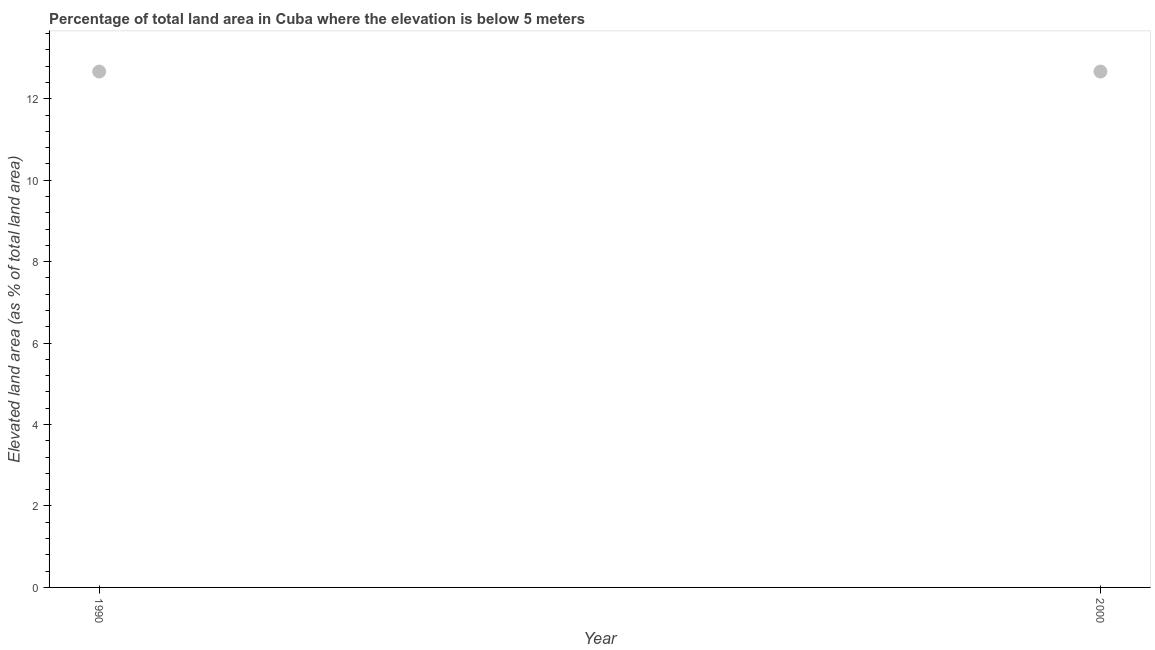What is the total elevated land area in 2000?
Offer a very short reply. 12.67. Across all years, what is the maximum total elevated land area?
Your response must be concise. 12.67. Across all years, what is the minimum total elevated land area?
Give a very brief answer. 12.67. In which year was the total elevated land area maximum?
Keep it short and to the point. 1990. What is the sum of the total elevated land area?
Your answer should be compact. 25.34. What is the average total elevated land area per year?
Make the answer very short. 12.67. What is the median total elevated land area?
Provide a short and direct response. 12.67. In how many years, is the total elevated land area greater than 7.2 %?
Your response must be concise. 2. Do a majority of the years between 2000 and 1990 (inclusive) have total elevated land area greater than 9.6 %?
Your response must be concise. No. What is the ratio of the total elevated land area in 1990 to that in 2000?
Offer a terse response. 1. Are the values on the major ticks of Y-axis written in scientific E-notation?
Provide a short and direct response. No. What is the title of the graph?
Provide a succinct answer. Percentage of total land area in Cuba where the elevation is below 5 meters. What is the label or title of the Y-axis?
Provide a short and direct response. Elevated land area (as % of total land area). What is the Elevated land area (as % of total land area) in 1990?
Make the answer very short. 12.67. What is the Elevated land area (as % of total land area) in 2000?
Provide a short and direct response. 12.67. What is the difference between the Elevated land area (as % of total land area) in 1990 and 2000?
Keep it short and to the point. 0. 